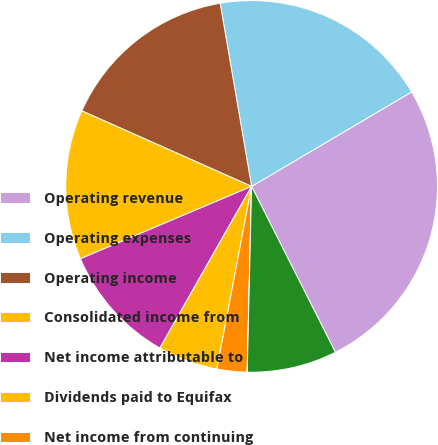Convert chart to OTSL. <chart><loc_0><loc_0><loc_500><loc_500><pie_chart><fcel>Operating revenue<fcel>Operating expenses<fcel>Operating income<fcel>Consolidated income from<fcel>Net income attributable to<fcel>Dividends paid to Equifax<fcel>Net income from continuing<fcel>Cash dividends declared per<fcel>Weighted-average shares<nl><fcel>26.04%<fcel>19.22%<fcel>15.63%<fcel>13.03%<fcel>10.42%<fcel>5.22%<fcel>2.61%<fcel>0.01%<fcel>7.82%<nl></chart> 